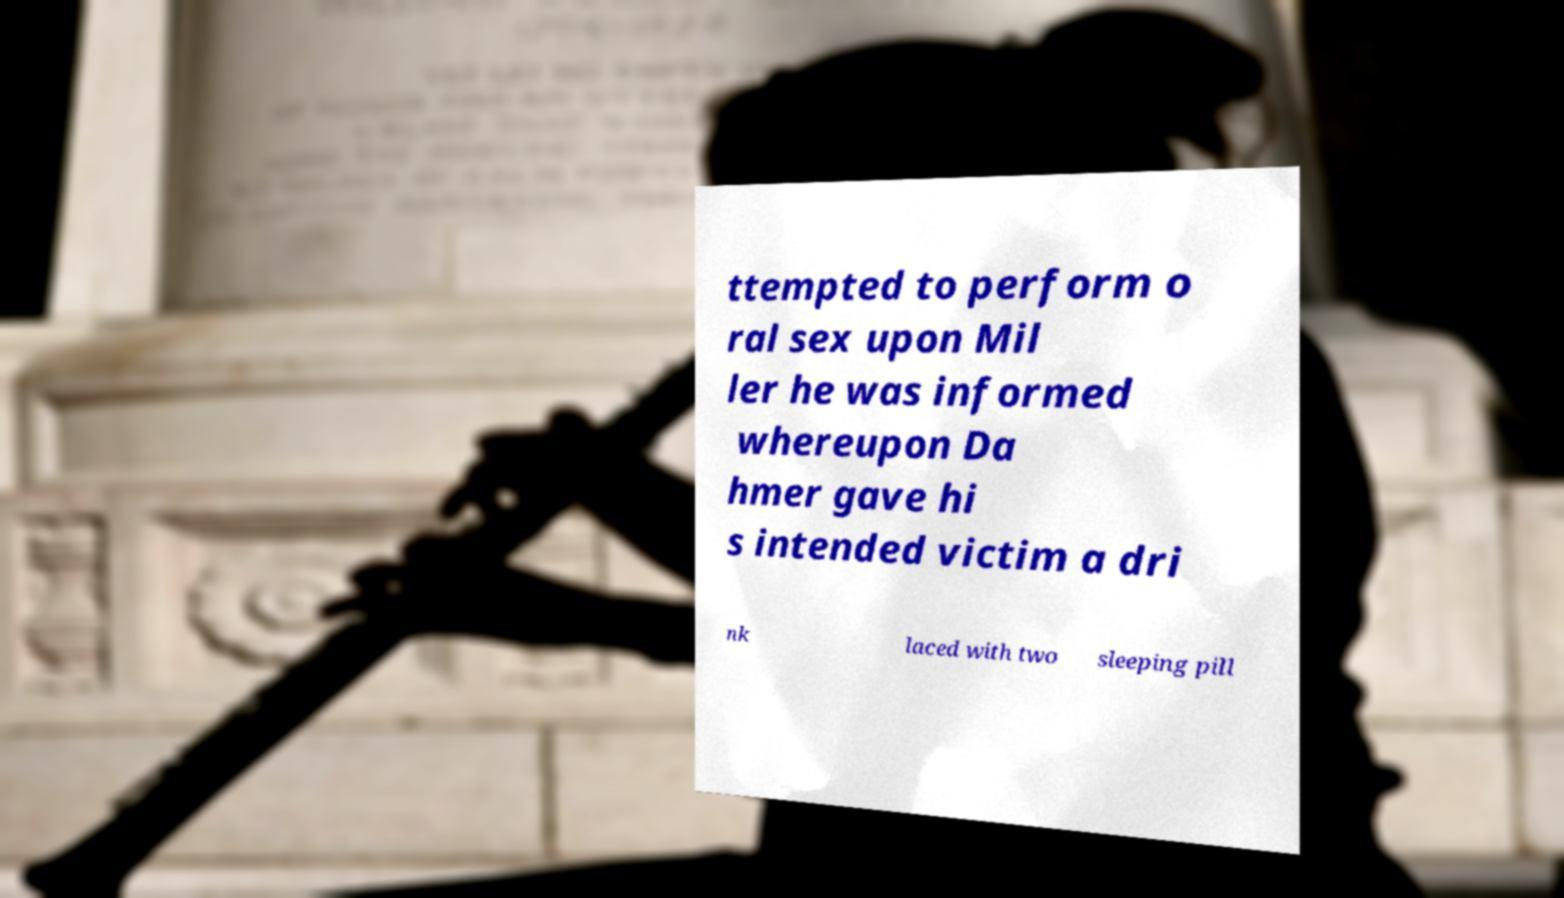Could you assist in decoding the text presented in this image and type it out clearly? ttempted to perform o ral sex upon Mil ler he was informed whereupon Da hmer gave hi s intended victim a dri nk laced with two sleeping pill 